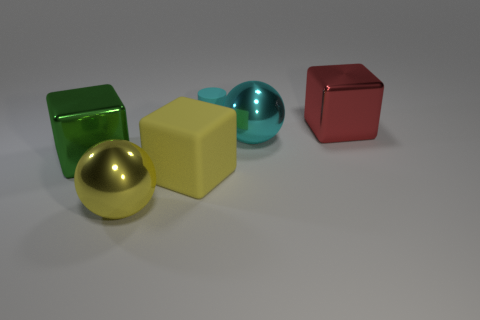Is there any other thing that is made of the same material as the big cyan object?
Your response must be concise. Yes. The small object is what color?
Offer a very short reply. Cyan. Do the rubber cylinder and the big rubber block have the same color?
Provide a succinct answer. No. There is a rubber cube on the left side of the red block; what number of rubber cylinders are behind it?
Give a very brief answer. 1. There is a block that is to the left of the large cyan metallic object and to the right of the big yellow ball; how big is it?
Offer a very short reply. Large. There is a cyan object that is in front of the tiny cyan rubber cylinder; what is it made of?
Offer a terse response. Metal. Is there a purple shiny thing that has the same shape as the big cyan object?
Give a very brief answer. No. What number of other metallic objects have the same shape as the green object?
Keep it short and to the point. 1. There is a cyan object behind the red shiny block; is it the same size as the yellow thing that is behind the large yellow metallic thing?
Provide a short and direct response. No. What is the shape of the cyan object in front of the shiny block that is on the right side of the yellow shiny sphere?
Make the answer very short. Sphere. 